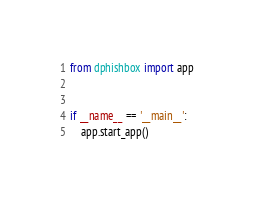<code> <loc_0><loc_0><loc_500><loc_500><_Python_>from dphishbox import app


if __name__ == '__main__':
    app.start_app()
</code> 